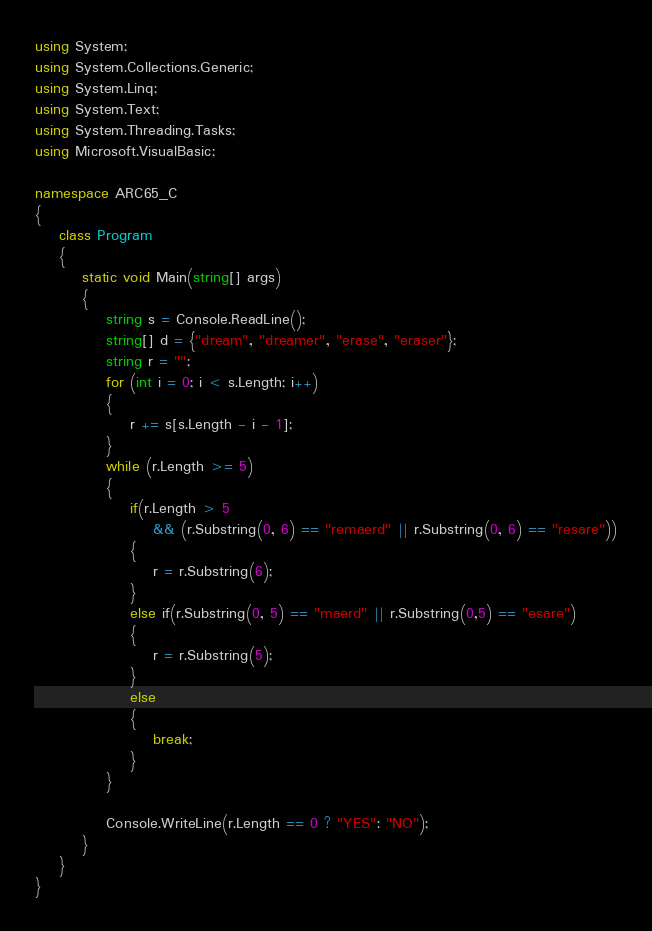Convert code to text. <code><loc_0><loc_0><loc_500><loc_500><_C#_>using System;
using System.Collections.Generic;
using System.Linq;
using System.Text;
using System.Threading.Tasks;
using Microsoft.VisualBasic;

namespace ARC65_C
{
    class Program
    {
        static void Main(string[] args)
        {
            string s = Console.ReadLine();
            string[] d = {"dream", "dreamer", "erase", "eraser"};
            string r = "";
            for (int i = 0; i < s.Length; i++)
            {
                r += s[s.Length - i - 1];
            }
            while (r.Length >= 5)
            {
                if(r.Length > 5 
                    && (r.Substring(0, 6) == "remaerd" || r.Substring(0, 6) == "resare"))
                {
                    r = r.Substring(6);
                }
                else if(r.Substring(0, 5) == "maerd" || r.Substring(0,5) == "esare")
                {
                    r = r.Substring(5);
                }
                else
                {
                    break;
                }
            }

            Console.WriteLine(r.Length == 0 ? "YES": "NO");
        }
    }
}
</code> 